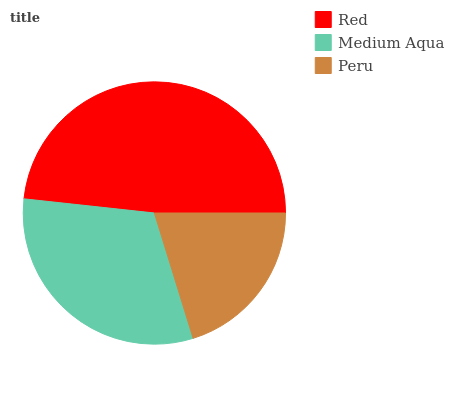Is Peru the minimum?
Answer yes or no. Yes. Is Red the maximum?
Answer yes or no. Yes. Is Medium Aqua the minimum?
Answer yes or no. No. Is Medium Aqua the maximum?
Answer yes or no. No. Is Red greater than Medium Aqua?
Answer yes or no. Yes. Is Medium Aqua less than Red?
Answer yes or no. Yes. Is Medium Aqua greater than Red?
Answer yes or no. No. Is Red less than Medium Aqua?
Answer yes or no. No. Is Medium Aqua the high median?
Answer yes or no. Yes. Is Medium Aqua the low median?
Answer yes or no. Yes. Is Peru the high median?
Answer yes or no. No. Is Peru the low median?
Answer yes or no. No. 